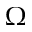Convert formula to latex. <formula><loc_0><loc_0><loc_500><loc_500>\Omega</formula> 